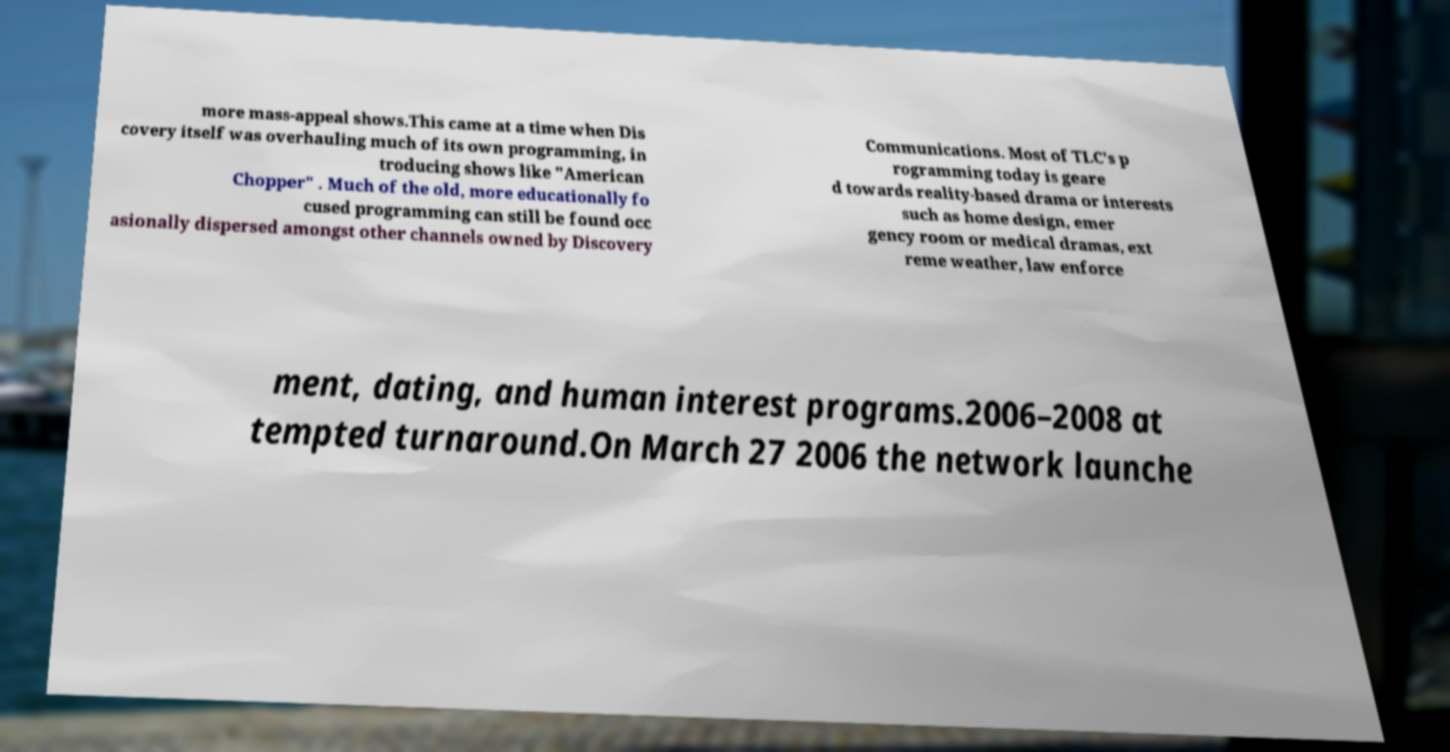Can you accurately transcribe the text from the provided image for me? more mass-appeal shows.This came at a time when Dis covery itself was overhauling much of its own programming, in troducing shows like "American Chopper" . Much of the old, more educationally fo cused programming can still be found occ asionally dispersed amongst other channels owned by Discovery Communications. Most of TLC's p rogramming today is geare d towards reality-based drama or interests such as home design, emer gency room or medical dramas, ext reme weather, law enforce ment, dating, and human interest programs.2006–2008 at tempted turnaround.On March 27 2006 the network launche 